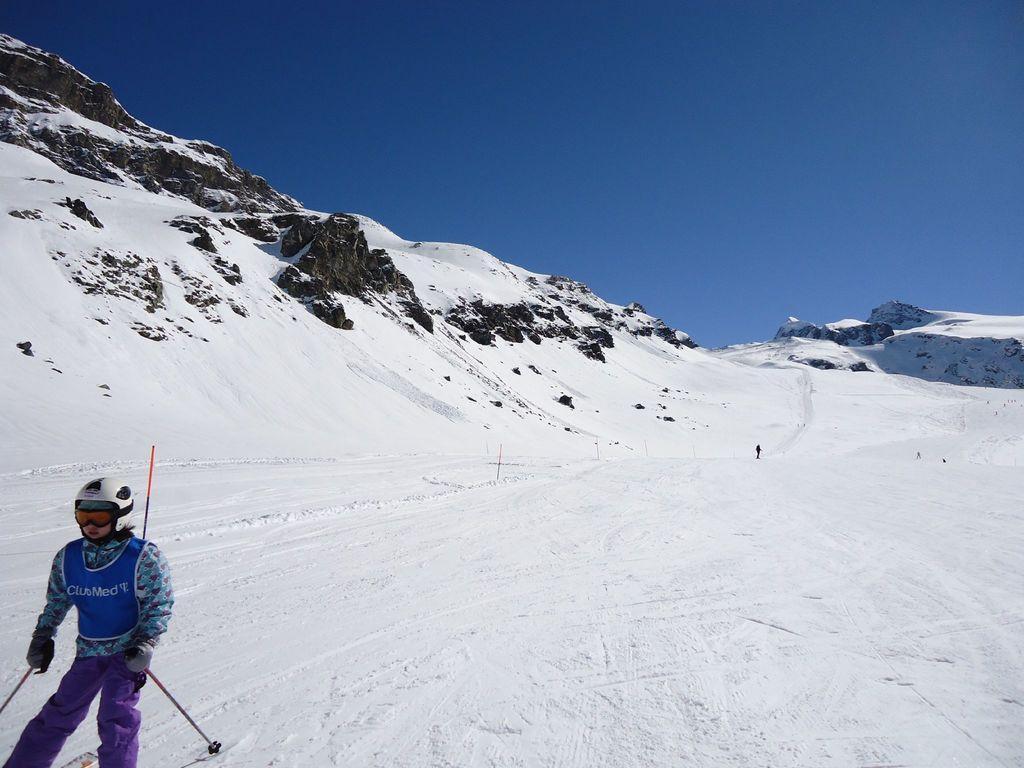In one or two sentences, can you explain what this image depicts? In this image on the left side I can see a person. I can see the snow on the hill. At the top I can see the sky. 